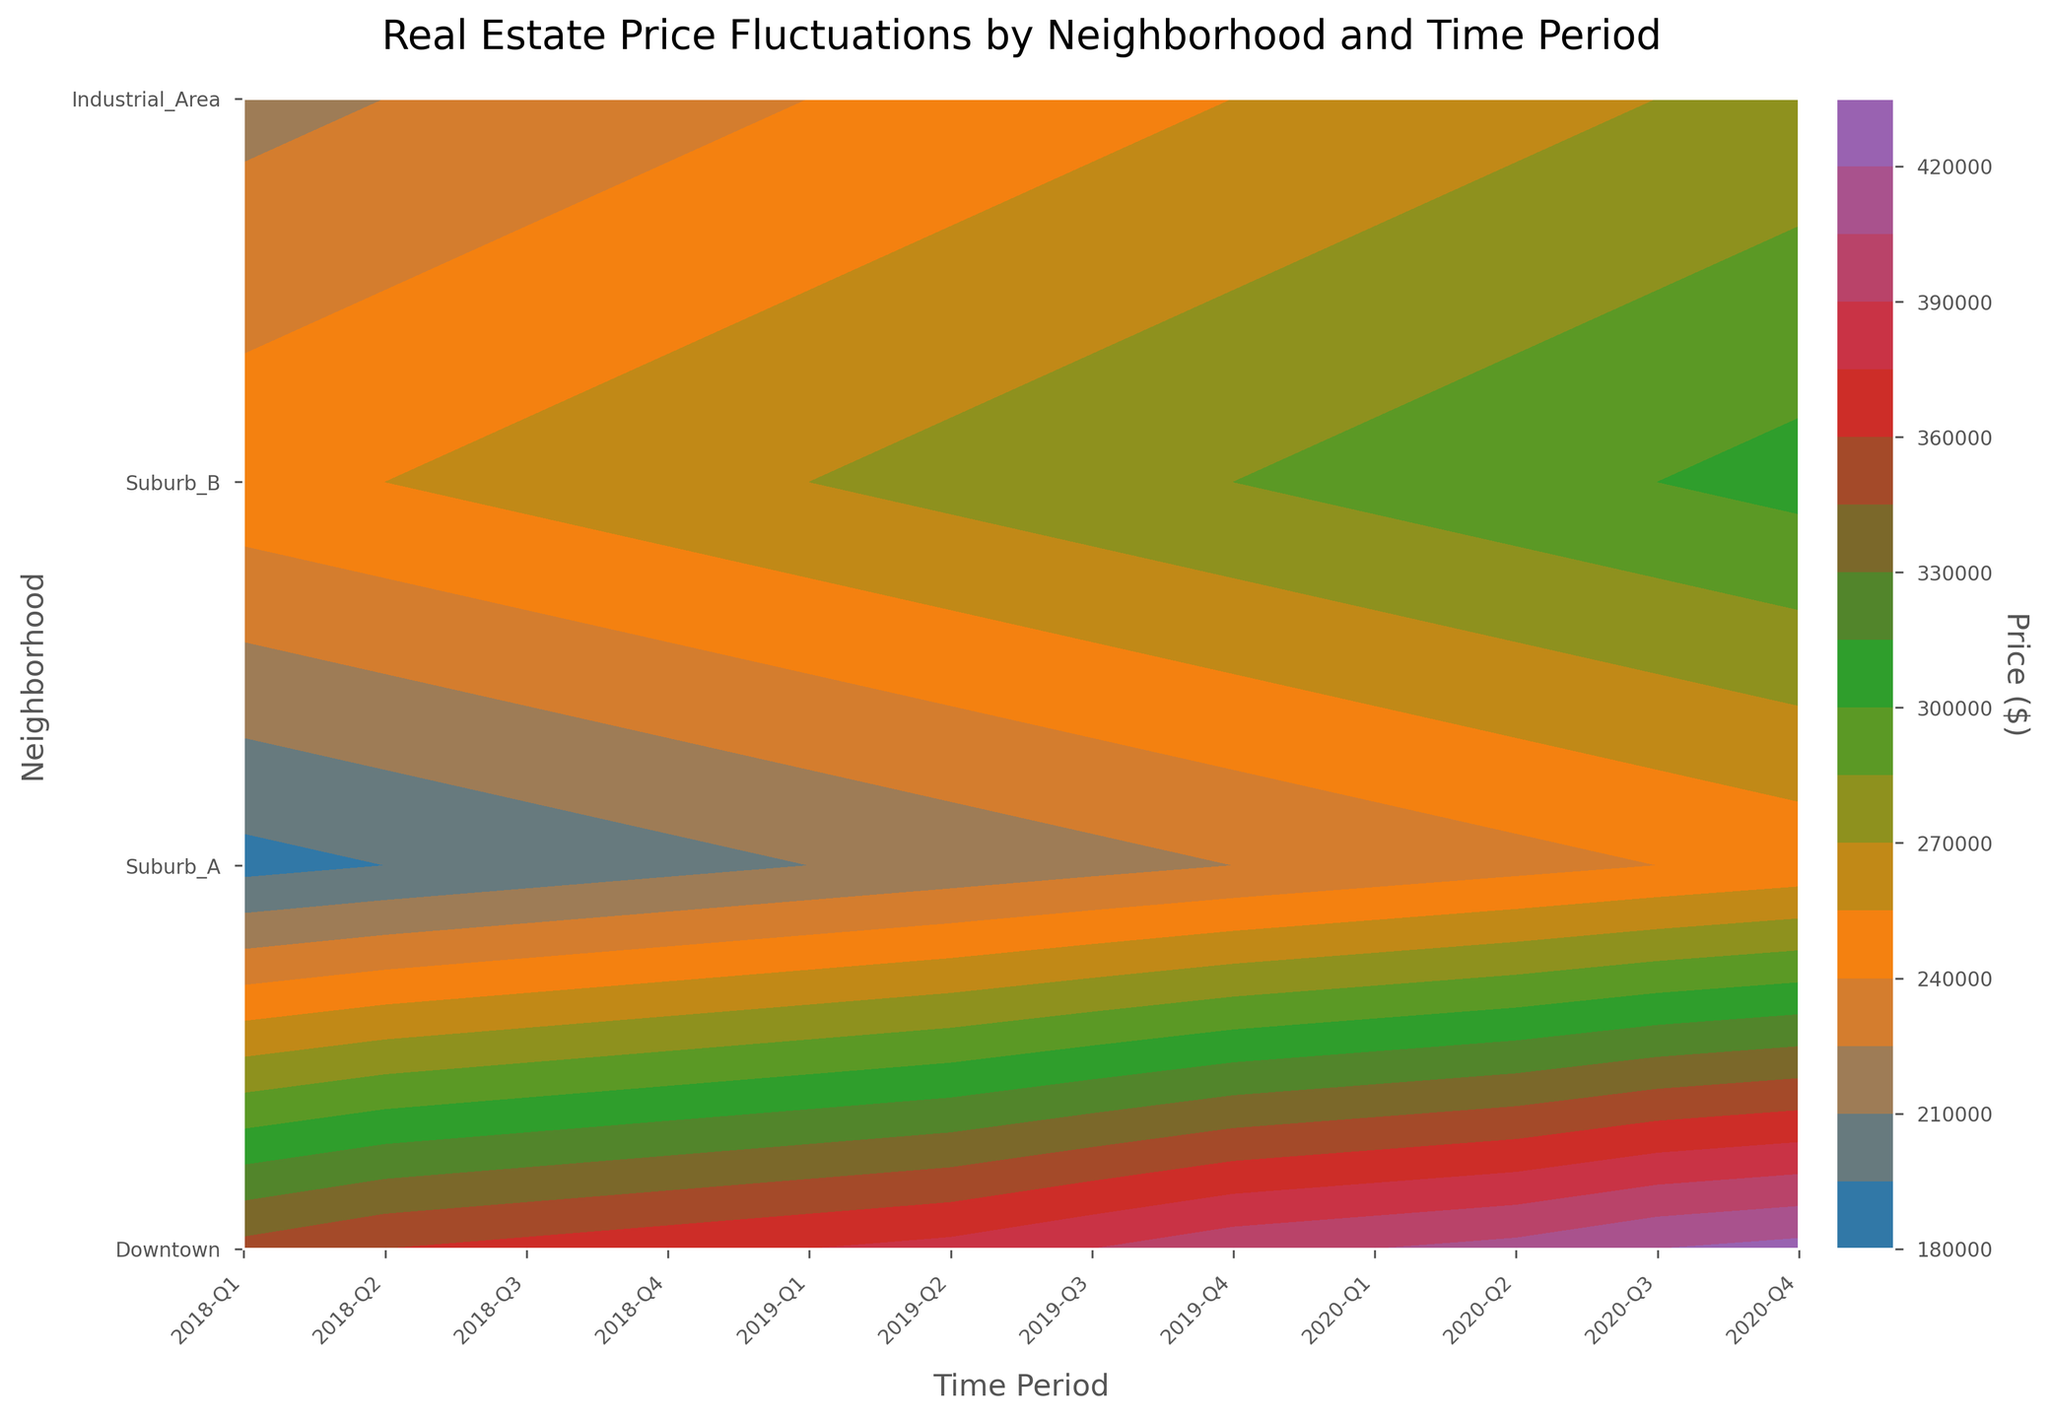What's the title of the plot? The title of the plot is usually located at the top center of the figure. Look for a larger, bolder text.
Answer: Real Estate Price Fluctuations by Neighborhood and Time Period Which neighborhood had the highest price in 2020-Q4? To identify the highest price in 2020-Q4, locate the 2020-Q4 time period on the x-axis and check the color intensity for each neighborhood. The neighborhood with the darkest shade has the highest price.
Answer: Downtown Which neighborhood had the lowest price in 2018-Q1? Locate the 2018-Q1 time period on the x-axis and observe the color intensity for each neighborhood. The neighborhood with the lightest shade has the lowest price.
Answer: Industrial_Area How much did the price in Downtown increase from 2018-Q1 to 2020-Q4? Find the price for Downtown in 2018-Q1 and 2020-Q4 on the plot. Calculate the difference by subtracting the price in 2018-Q1 from the price in 2020-Q4.
Answer: $75,000 Compare the price trends between Suburb_A and Suburb_B from 2018-Q1 to 2020-Q4. Which neighborhood had a steeper increase? Check the color gradient from 2018-Q1 to 2020-Q4 for both Suburb_A and Suburb_B. The neighborhood with the more significant change in color intensity has a steeper increase.
Answer: Suburb_A What is the general trend in real estate prices in the Industrial Area from 2018-Q1 to 2020-Q4? Observe the change in color intensity in the Industrial Area from the beginning to the end of the time period. A gradual increase in color intensity indicates a general increase in prices.
Answer: Increasing In which neighborhood did the price increases become notably steeper in recent periods? Look for a neighborhood where the color gradient changes more dramatically in the later time periods.
Answer: Downtown Which time period shows the largest price change within any neighborhood? Compare the color gradients for each neighborhood across different time periods. Identify the period with the most considerable shift from one quarter to the next.
Answer: 2019-Q4 to 2020-Q1 for Suburb_B Between Downtown and Suburb_A, which one had more consistent price growth? Consistent price growth is indicated by a uniform color gradient. Compare the color gradients across time periods for both neighborhoods.
Answer: Suburb_A How does the price in Suburb_B in 2020-Q3 compare to the price in Industrial_Area in 2020-Q4? Find these two data points and compare their color intensities. The darker color indicates a higher price.
Answer: Suburb_B is higher 